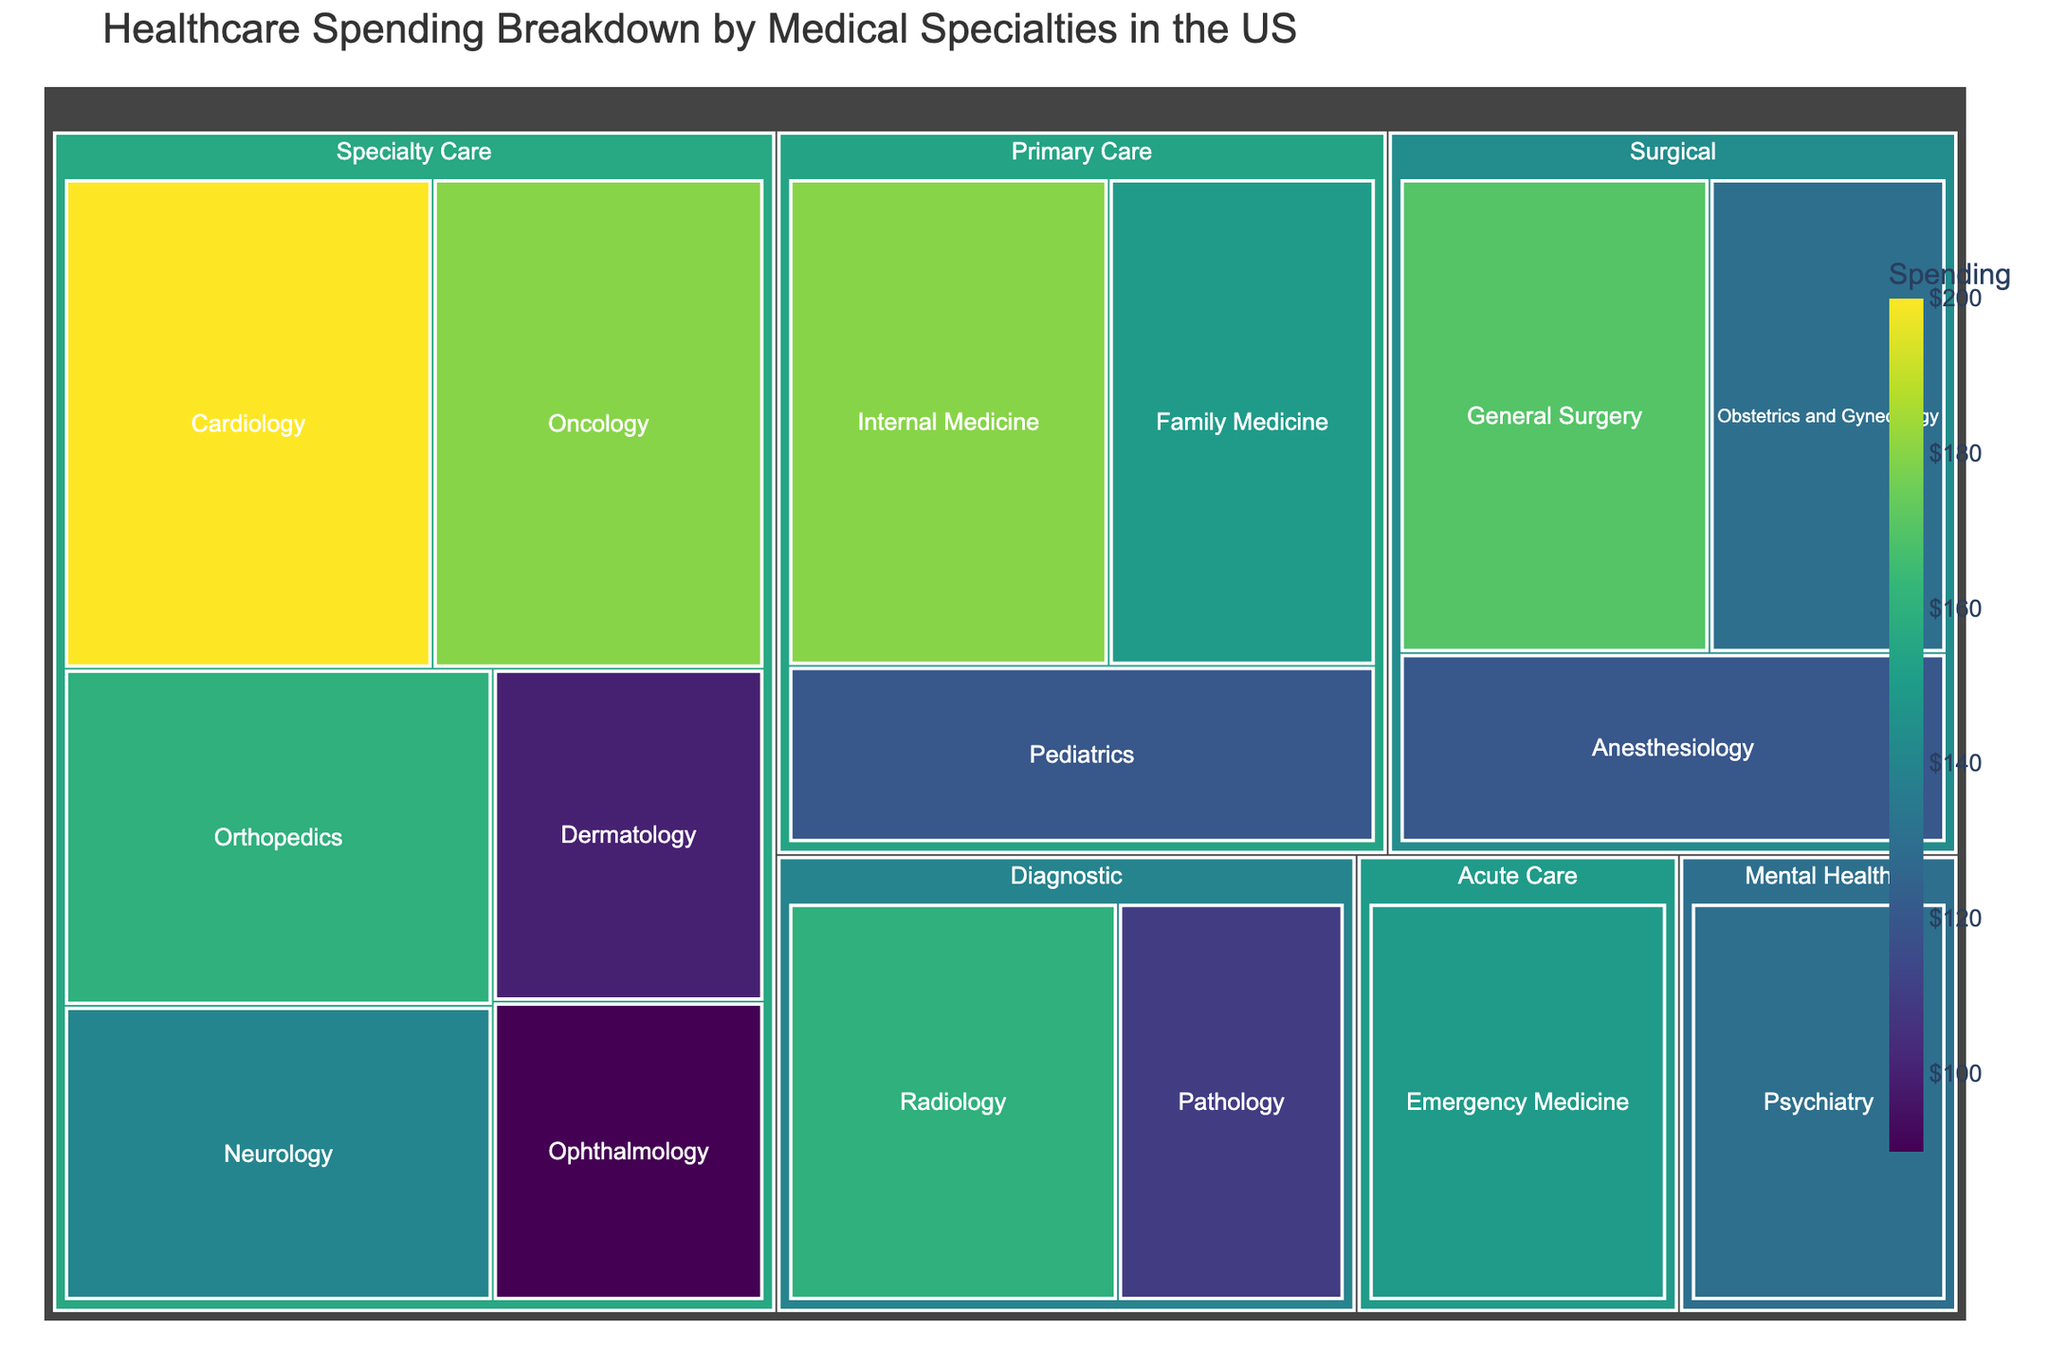How is the healthcare spending distributed among the medical categories? To answer, look at the size of the rectangles for each medical category in the Treemap. The larger the rectangle, the higher the spending. Compare the areas visually.
Answer: Specialty Care has the highest, followed by Primary Care, Surgical, Diagnostic, Mental Health, and Acute Care Which medical specialty has the highest spending and what is its amount? Identify the largest individual rectangle in the Treemap, which corresponds to the highest spending specialty. The amount is shown within or near the rectangle.
Answer: Cardiology, $200M What's the combined spending of Primary Care specialties? Sum up spending values for Internal Medicine, Family Medicine, and Pediatrics from the Primary Care category.
Answer: $450M Compare the spending between General Surgery and Anesthesiology. Which is higher and by how much? Check the spending values for General Surgery ($170M) and Anesthesiology ($120M). Subtract the smaller from the bigger.
Answer: General Surgery is higher by $50M Identify the smallest spending specialty and provide its value. Look for the smallest rectangle in the Treemap and read the corresponding value.
Answer: Ophthalmology, $90M What's the total spending for Diagnostic specialties? Sum up the spending values for Radiology and Pathology under the Diagnostic category.
Answer: $270M Which medical category has more spending, Surgical or Diagnostic? Compare the combined spending of General Surgery, Obstetrics and Gynecology, and Anesthesiology with the combined spending of Radiology and Pathology.
Answer: Surgical What is the difference in spending between Emergency Medicine and Psychiatry? Find the spending values for Emergency Medicine ($150M) and Psychiatry ($130M). Subtract the smaller from the bigger.
Answer: $20M What percentage of the total spending does Oncology represent? Sum up all spending values to get total spending. Divide Oncology’s spending by total spending and multiply by 100.
Answer: 10.5% Which specialty in Specialty Care has the lowest spending and what is its value? Look within the Specialty Care category for the smallest rectangle.
Answer: Ophthalmology, $90M 